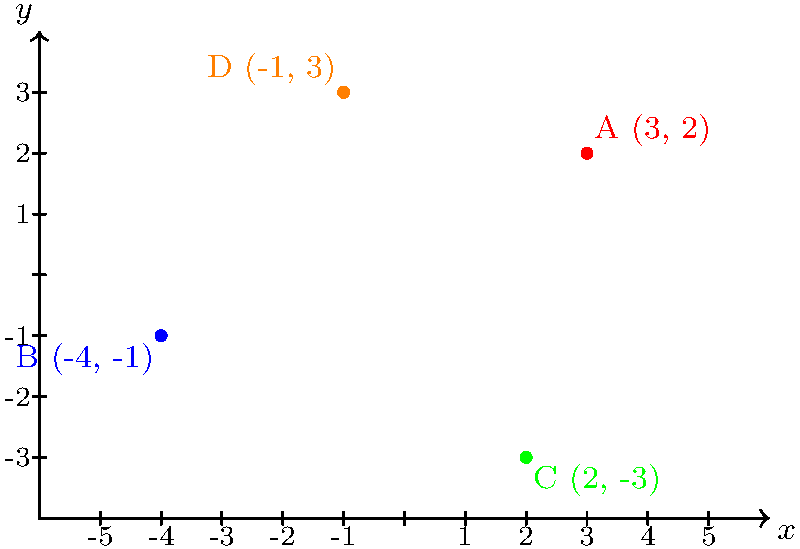In a volleyball match against the Merrimack Warriors, your team's players are positioned on the court as shown in the coordinate plane above. The origin (0,0) represents the center of the court. Identify the quadrant in which each player (A, B, C, and D) is located. To determine the quadrant for each player, we need to recall the quadrant definitions:

1. Quadrant I: Both $x$ and $y$ coordinates are positive $(+,+)$
2. Quadrant II: $x$ is negative, $y$ is positive $(-,+)$
3. Quadrant III: Both $x$ and $y$ coordinates are negative $(-,-)$
4. Quadrant IV: $x$ is positive, $y$ is negative $(+,-)$

Now, let's analyze each player's position:

1. Player A (3, 2):
   $x = 3$ (positive), $y = 2$ (positive)
   This falls in Quadrant I

2. Player B (-4, -1):
   $x = -4$ (negative), $y = -1$ (negative)
   This falls in Quadrant III

3. Player C (2, -3):
   $x = 2$ (positive), $y = -3$ (negative)
   This falls in Quadrant IV

4. Player D (-1, 3):
   $x = -1$ (negative), $y = 3$ (positive)
   This falls in Quadrant II
Answer: A: I, B: III, C: IV, D: II 